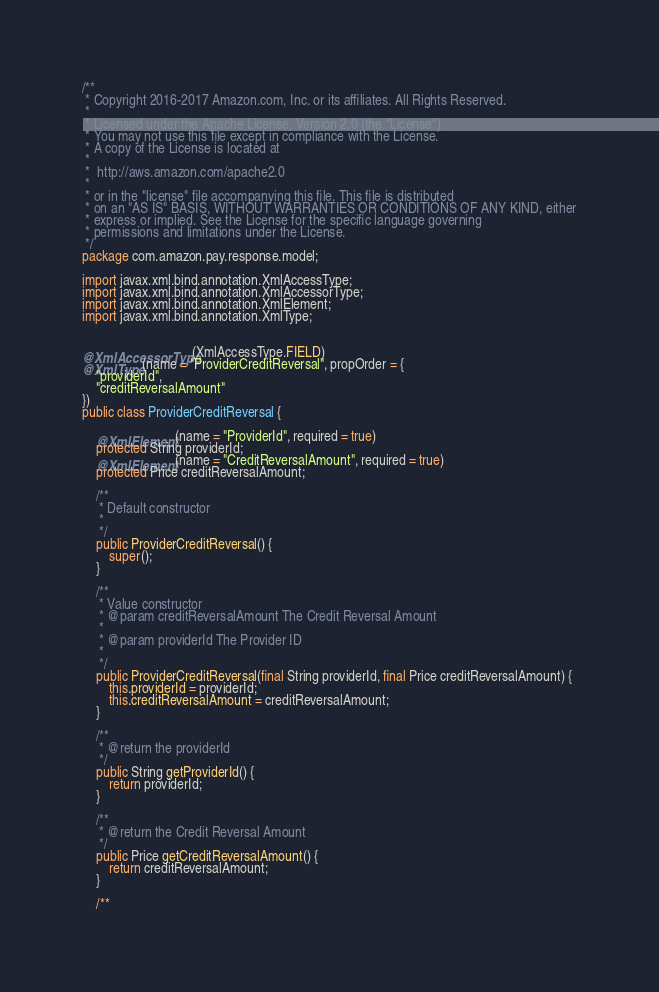<code> <loc_0><loc_0><loc_500><loc_500><_Java_>/**
 * Copyright 2016-2017 Amazon.com, Inc. or its affiliates. All Rights Reserved.
 *
 * Licensed under the Apache License, Version 2.0 (the "License").
 * You may not use this file except in compliance with the License.
 * A copy of the License is located at
 *
 *  http://aws.amazon.com/apache2.0
 *
 * or in the "license" file accompanying this file. This file is distributed
 * on an "AS IS" BASIS, WITHOUT WARRANTIES OR CONDITIONS OF ANY KIND, either
 * express or implied. See the License for the specific language governing
 * permissions and limitations under the License.
 */
package com.amazon.pay.response.model;

import javax.xml.bind.annotation.XmlAccessType;
import javax.xml.bind.annotation.XmlAccessorType;
import javax.xml.bind.annotation.XmlElement;
import javax.xml.bind.annotation.XmlType;


@XmlAccessorType(XmlAccessType.FIELD)
@XmlType(name = "ProviderCreditReversal", propOrder = {
    "providerId",
    "creditReversalAmount"
})
public class ProviderCreditReversal {

    @XmlElement(name = "ProviderId", required = true)
    protected String providerId;
    @XmlElement(name = "CreditReversalAmount", required = true)
    protected Price creditReversalAmount;

    /**
     * Default constructor
     * 
     */
    public ProviderCreditReversal() {
        super();
    }

    /**
     * Value constructor
     * @param creditReversalAmount The Credit Reversal Amount
     *
     * @param providerId The Provider ID
     * 
     */
    public ProviderCreditReversal(final String providerId, final Price creditReversalAmount) {
        this.providerId = providerId;
        this.creditReversalAmount = creditReversalAmount;
    }

    /**
     * @return the providerId
     */
    public String getProviderId() {
        return providerId;
    }

    /**
     * @return the Credit Reversal Amount
     */
    public Price getCreditReversalAmount() {
        return creditReversalAmount;
    }

    /**</code> 